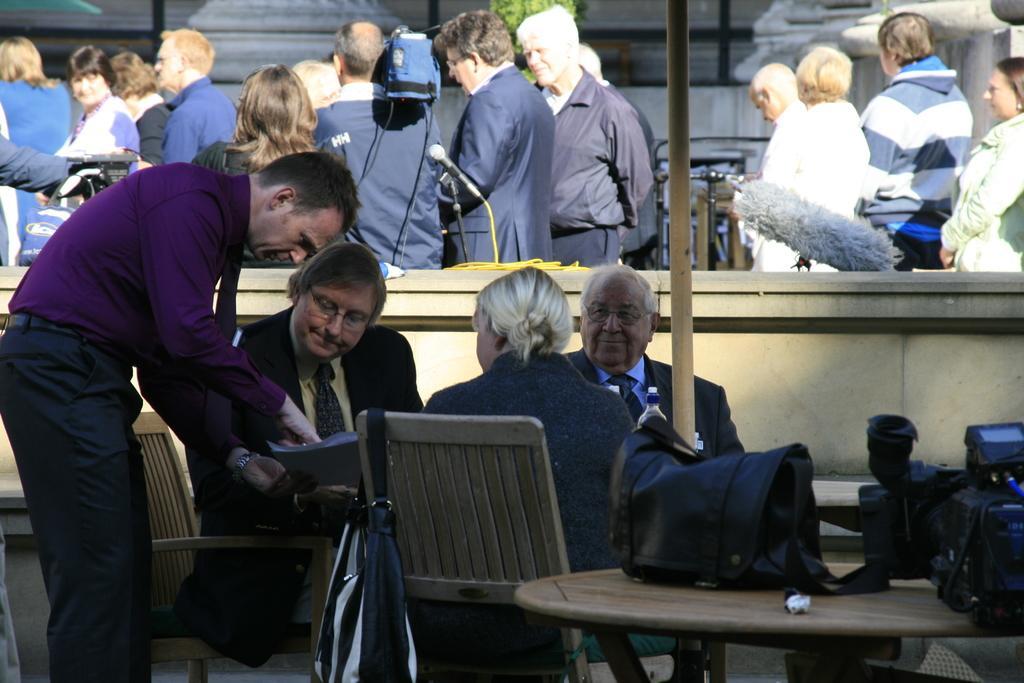Describe this image in one or two sentences. In the picture there are few people sat on chairs around table in front. this seems to be in conference hall, in the background there are many people stood. 